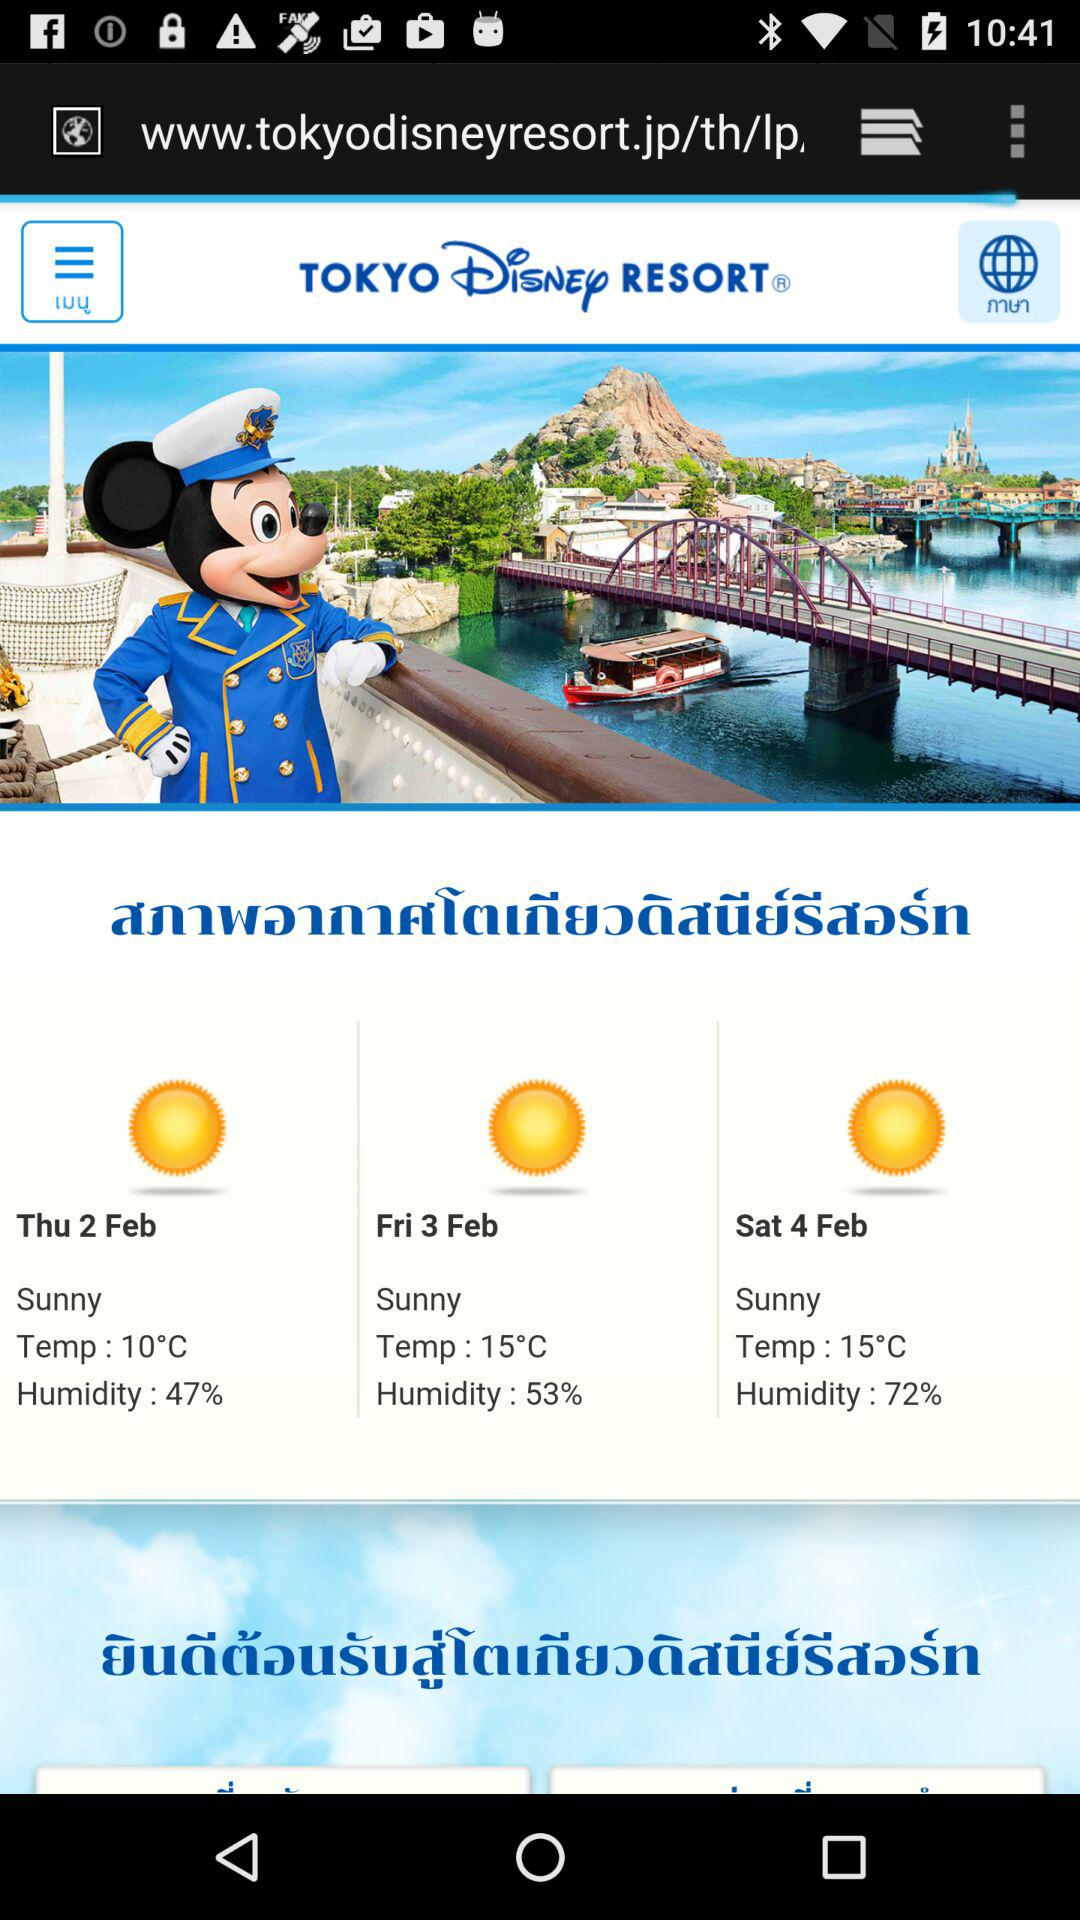What is the highest temperature in the weather forecast?
Answer the question using a single word or phrase. 15°C 